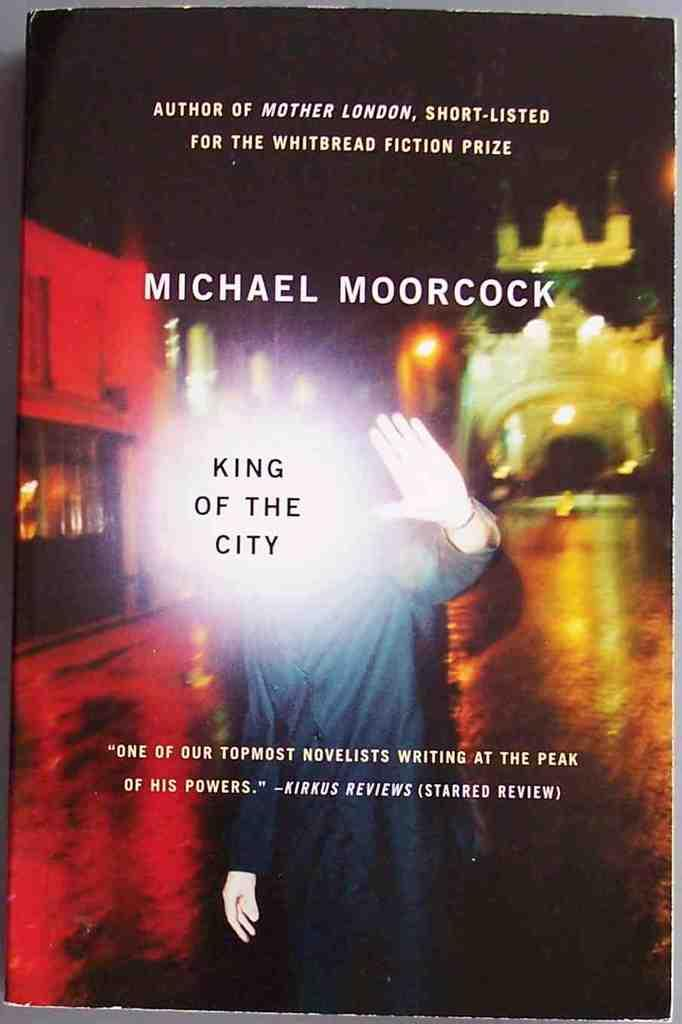<image>
Create a compact narrative representing the image presented. The book entitled King of the City written by Michael Moorcock. 